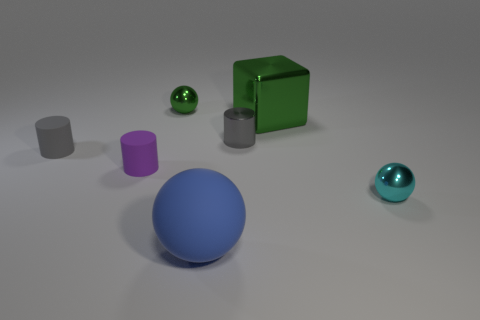Add 1 big blocks. How many objects exist? 8 Subtract all gray cylinders. How many cylinders are left? 1 Subtract all cylinders. How many objects are left? 4 Add 7 small green metallic spheres. How many small green metallic spheres are left? 8 Add 5 big rubber things. How many big rubber things exist? 6 Subtract all blue balls. How many balls are left? 2 Subtract 0 green cylinders. How many objects are left? 7 Subtract 1 blocks. How many blocks are left? 0 Subtract all purple cylinders. Subtract all brown cubes. How many cylinders are left? 2 Subtract all purple cylinders. How many blue spheres are left? 1 